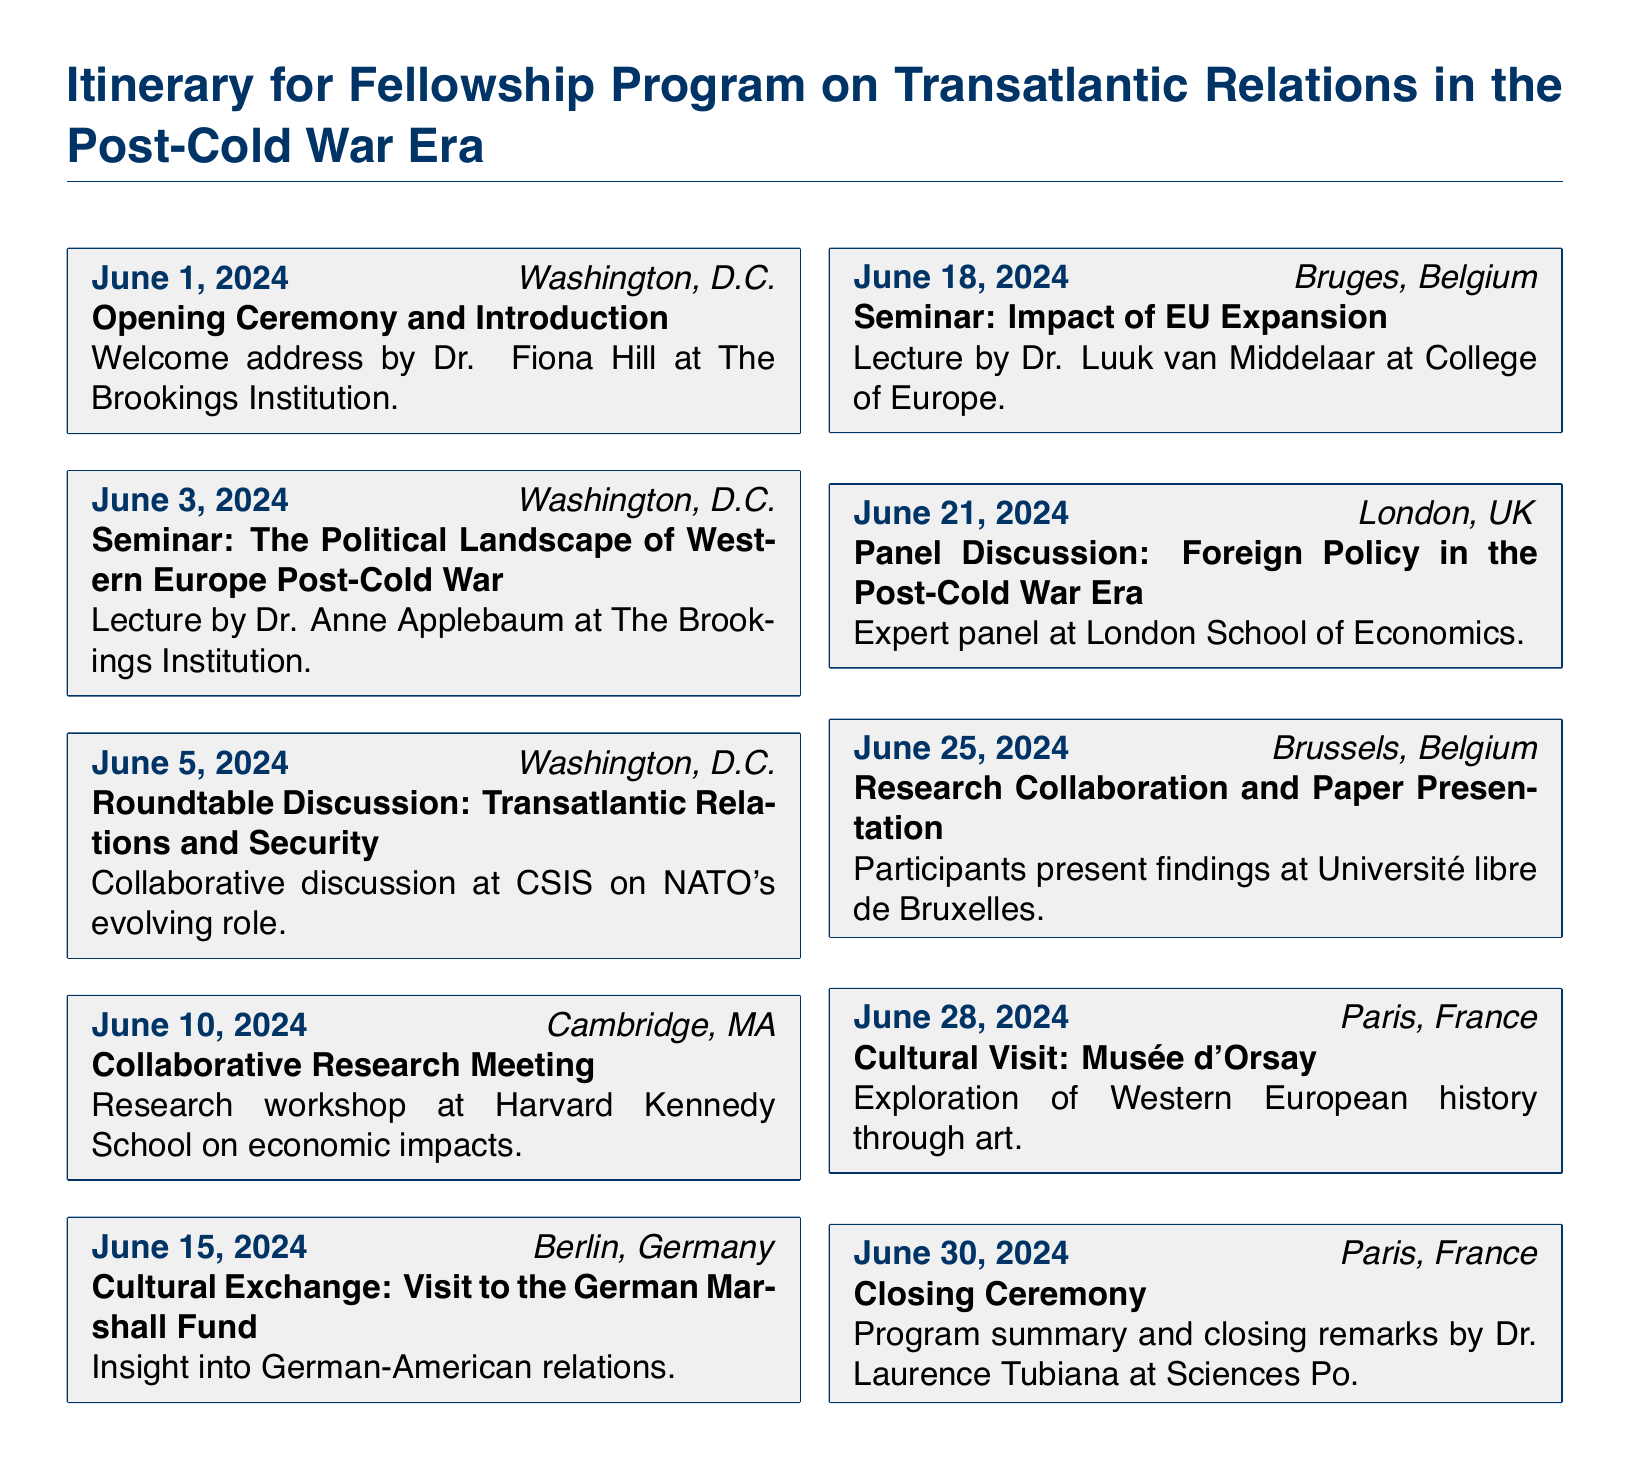What is the date of the opening ceremony? The opening ceremony is scheduled for June 1, 2024, as stated in the document.
Answer: June 1, 2024 Who delivers the welcome address at the opening ceremony? The document specifies Dr. Fiona Hill as the speaker for the welcome address.
Answer: Dr. Fiona Hill Where is the seminar on the political landscape of Western Europe held? It is mentioned that the seminar takes place at The Brookings Institution in Washington, D.C.
Answer: The Brookings Institution What is the focus of the seminar on June 18, 2024? According to the document, this seminar focuses on the impact of EU expansion.
Answer: Impact of EU Expansion How many events take place in Paris during the program? The itinerary lists two events taking place in Paris, one cultural visit and one closing ceremony.
Answer: Two What is the nature of the event on June 10, 2024? The document describes it as a collaborative research meeting at Harvard Kennedy School.
Answer: Collaborative Research Meeting In which city does the cultural exchange on June 15, 2024, occur? The cultural exchange takes place in Berlin, Germany, as indicated in the schedule.
Answer: Berlin, Germany What significant topic is discussed during the roundtable discussion on June 5, 2024? The roundtable discussion centers around transatlantic relations and NATO's evolving role.
Answer: Transatlantic relations and security What is the purpose of the event on June 25, 2024? The event is intended for research collaboration and paper presentation at Université libre de Bruxelles.
Answer: Research Collaboration and Paper Presentation 